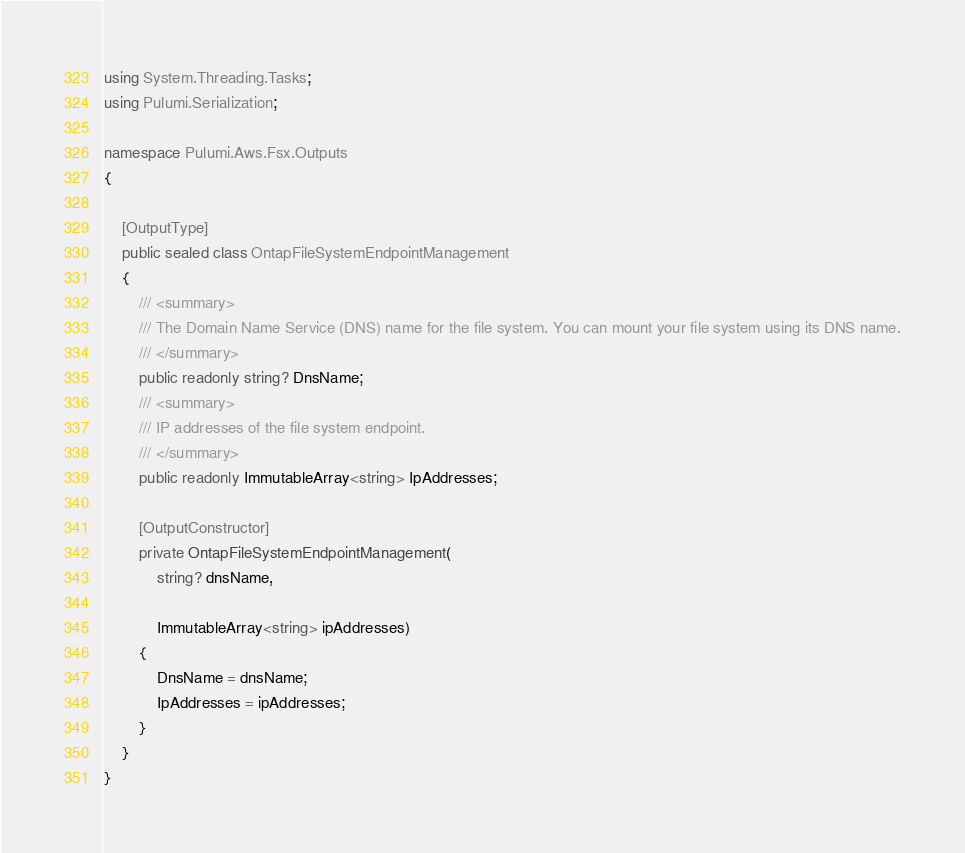Convert code to text. <code><loc_0><loc_0><loc_500><loc_500><_C#_>using System.Threading.Tasks;
using Pulumi.Serialization;

namespace Pulumi.Aws.Fsx.Outputs
{

    [OutputType]
    public sealed class OntapFileSystemEndpointManagement
    {
        /// <summary>
        /// The Domain Name Service (DNS) name for the file system. You can mount your file system using its DNS name.
        /// </summary>
        public readonly string? DnsName;
        /// <summary>
        /// IP addresses of the file system endpoint.
        /// </summary>
        public readonly ImmutableArray<string> IpAddresses;

        [OutputConstructor]
        private OntapFileSystemEndpointManagement(
            string? dnsName,

            ImmutableArray<string> ipAddresses)
        {
            DnsName = dnsName;
            IpAddresses = ipAddresses;
        }
    }
}
</code> 